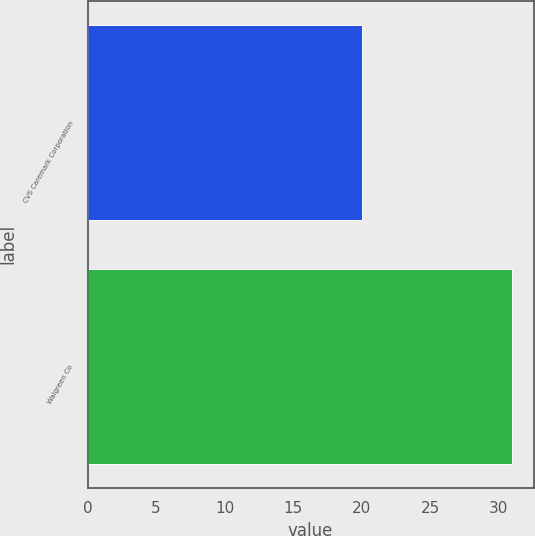Convert chart. <chart><loc_0><loc_0><loc_500><loc_500><bar_chart><fcel>CVS Caremark Corporation<fcel>Walgreen Co<nl><fcel>20<fcel>31<nl></chart> 